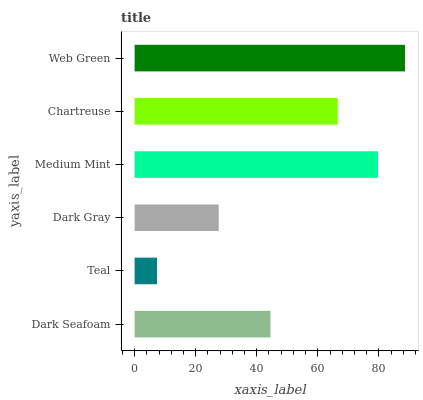Is Teal the minimum?
Answer yes or no. Yes. Is Web Green the maximum?
Answer yes or no. Yes. Is Dark Gray the minimum?
Answer yes or no. No. Is Dark Gray the maximum?
Answer yes or no. No. Is Dark Gray greater than Teal?
Answer yes or no. Yes. Is Teal less than Dark Gray?
Answer yes or no. Yes. Is Teal greater than Dark Gray?
Answer yes or no. No. Is Dark Gray less than Teal?
Answer yes or no. No. Is Chartreuse the high median?
Answer yes or no. Yes. Is Dark Seafoam the low median?
Answer yes or no. Yes. Is Dark Seafoam the high median?
Answer yes or no. No. Is Medium Mint the low median?
Answer yes or no. No. 